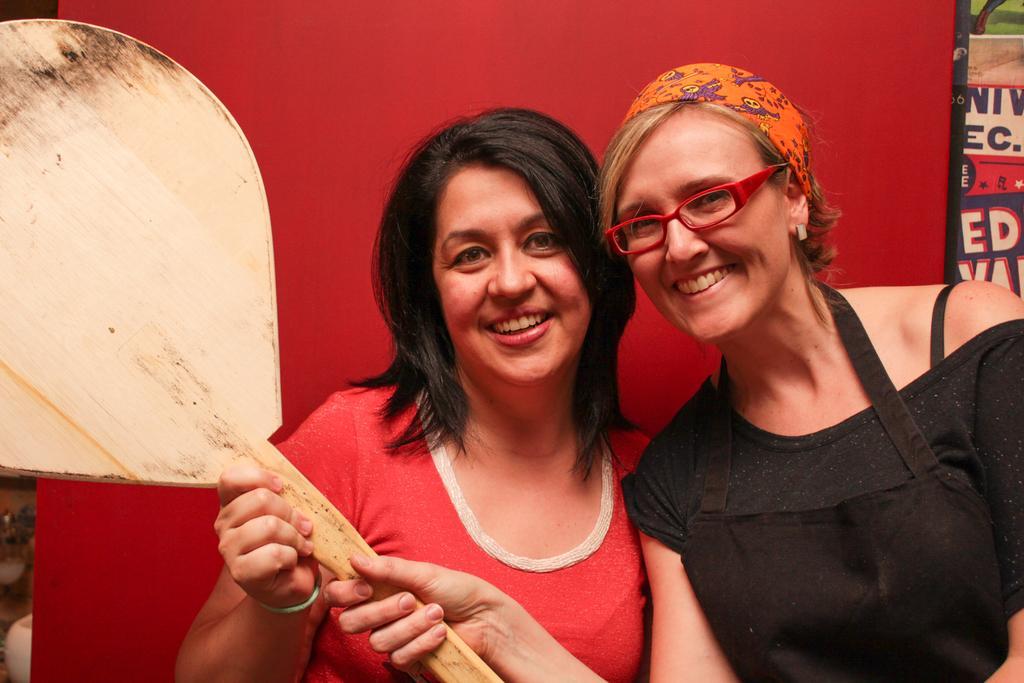In one or two sentences, can you explain what this image depicts? In this image I can see two women and I can see both of them are holding a wooden thing. I can also see smile on their faces and here I can see she is wearing a red color specs. I can also see one of them is wearing red color dress and one is wearing black. In the background I can see a red color thing and over there I can see something is written. 